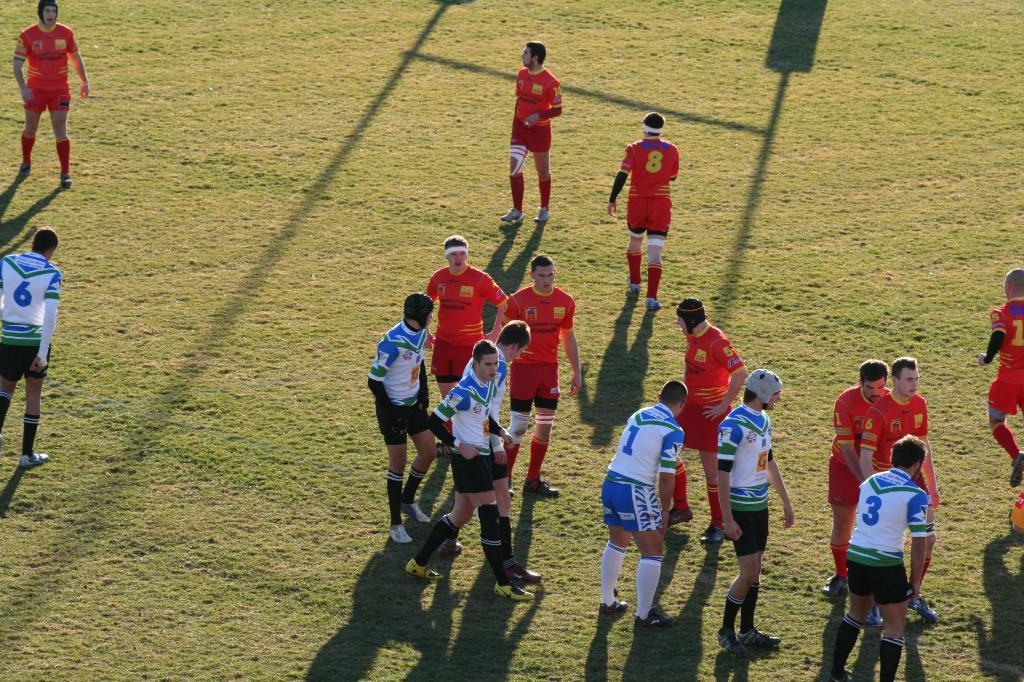<image>
Share a concise interpretation of the image provided. A rugby team about to get into action, featuring numbers 6, 1, 3. 